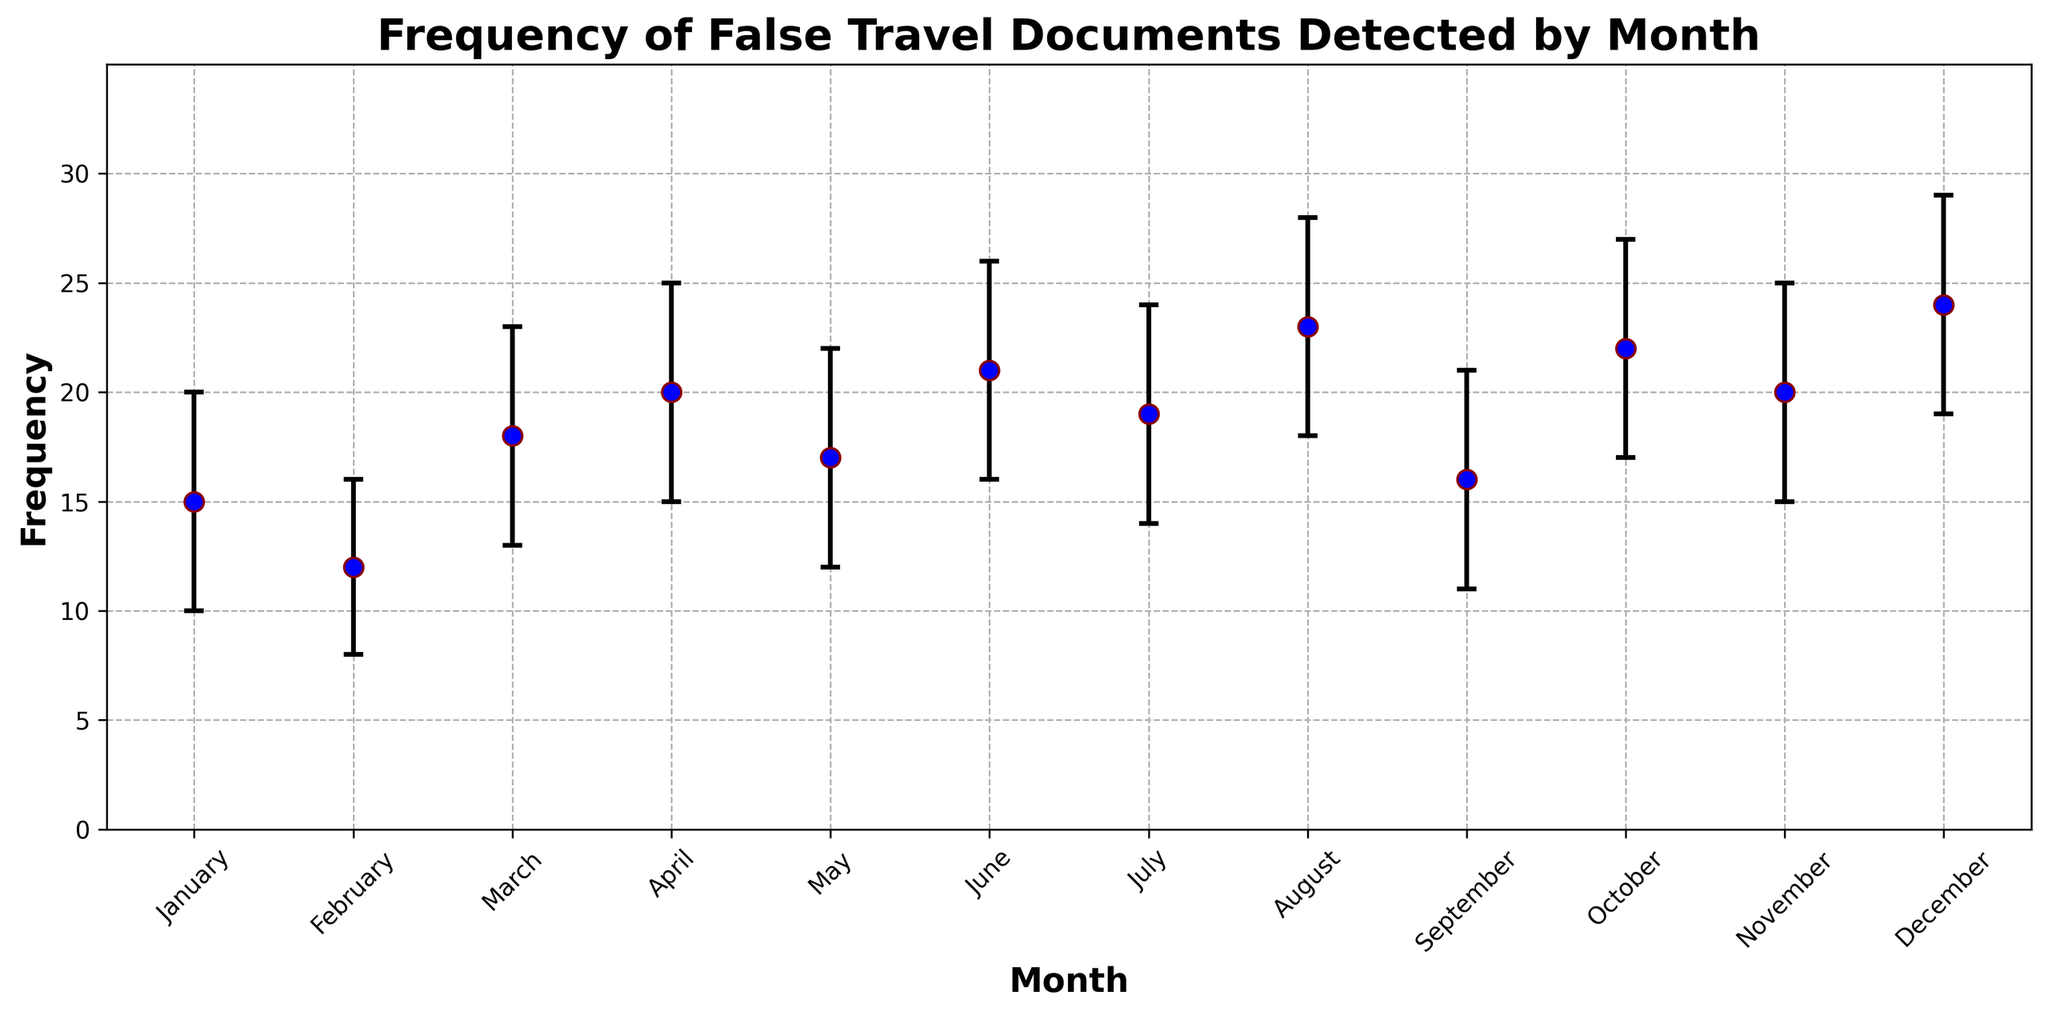Which month had the highest frequency of false travel documents detected? In the figure, look for the highest point on the chart. The frequency value in December is 24, which is the highest among all the months.
Answer: December Which months had a frequency of detected false travel documents equal to 20? Identify the months where the frequency is marked as 20. These months are April and November.
Answer: April and November What is the difference between the highest and lowest frequency of detected false travel documents? Identify the highest frequency and the lowest frequency from the chart. The highest is 24 (December) and the lowest is 12 (February). The difference is 24 - 12.
Answer: 12 In which month is the confidence interval range the largest? Analyze the error bars in the chart. The largest confidence interval range is found in December, where the interval is from 19 to 29, giving a range of 10.
Answer: December What is the average frequency of detected false travel documents for the first quarter (January to March)? Sum the frequencies for January, February, and March (15 + 12 + 18), then divide by 3 to find the average.
Answer: 15 In which month does the upper confidence interval reach 28? Identify the month(s) where the upper end of the error bar touches 28. This occurs in August.
Answer: August What is the change in frequency of detected false travel documents from May to June? Find the frequency for both May and June, then calculate the difference (21 - 17).
Answer: 4 Which months have a frequency higher than 20? Identify the months where the frequency is greater than 20. These months are June, August, October, and December.
Answer: June, August, October, and December How many months have confidence intervals that include 15? Check the error bars for each month to see where 15 is within the range of the confidence interval. The months that include 15 are February, March, April, May, September, November, and December.
Answer: 7 months What is the median frequency of false travel documents detected throughout the year? Arrange the frequencies in ascending order (12, 15, 16, 17, 18, 19, 20, 20, 21, 22, 23, 24). The median is the average of the 6th and 7th values (19 and 20).
Answer: 19.5 